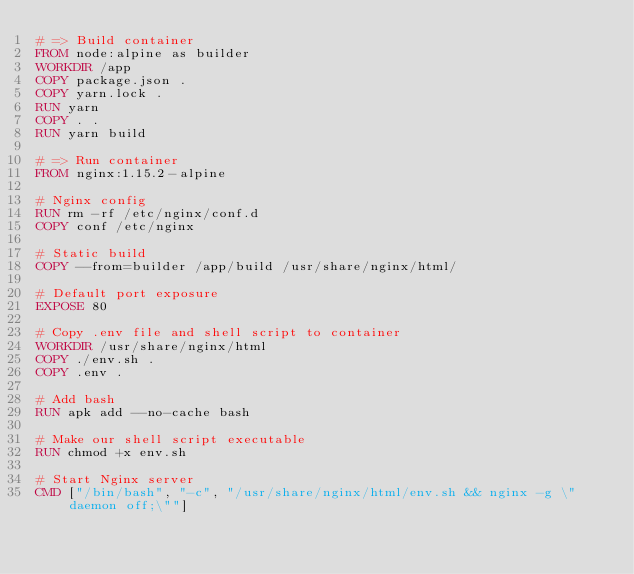Convert code to text. <code><loc_0><loc_0><loc_500><loc_500><_Dockerfile_># => Build container
FROM node:alpine as builder
WORKDIR /app
COPY package.json .
COPY yarn.lock .
RUN yarn
COPY . .
RUN yarn build

# => Run container
FROM nginx:1.15.2-alpine

# Nginx config
RUN rm -rf /etc/nginx/conf.d
COPY conf /etc/nginx

# Static build
COPY --from=builder /app/build /usr/share/nginx/html/

# Default port exposure
EXPOSE 80

# Copy .env file and shell script to container
WORKDIR /usr/share/nginx/html
COPY ./env.sh .
COPY .env .

# Add bash
RUN apk add --no-cache bash

# Make our shell script executable
RUN chmod +x env.sh

# Start Nginx server
CMD ["/bin/bash", "-c", "/usr/share/nginx/html/env.sh && nginx -g \"daemon off;\""]</code> 